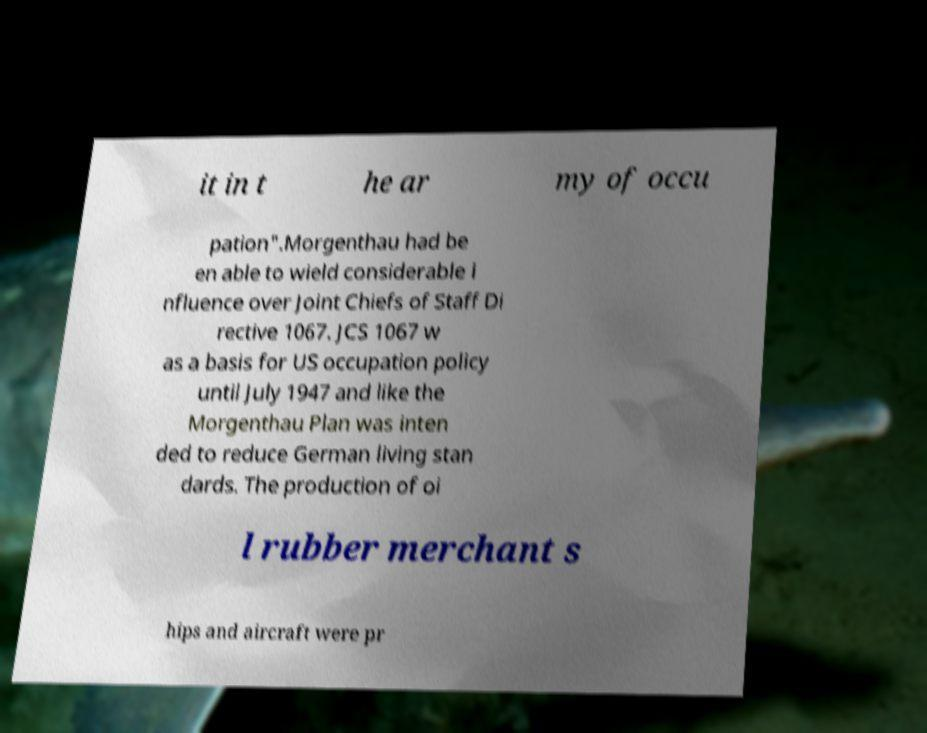For documentation purposes, I need the text within this image transcribed. Could you provide that? it in t he ar my of occu pation".Morgenthau had be en able to wield considerable i nfluence over Joint Chiefs of Staff Di rective 1067. JCS 1067 w as a basis for US occupation policy until July 1947 and like the Morgenthau Plan was inten ded to reduce German living stan dards. The production of oi l rubber merchant s hips and aircraft were pr 